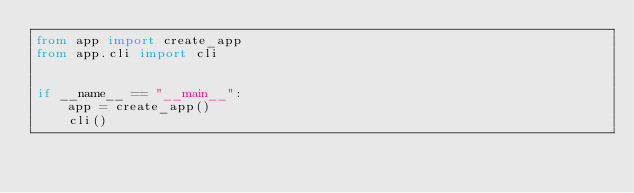<code> <loc_0><loc_0><loc_500><loc_500><_Python_>from app import create_app
from app.cli import cli


if __name__ == "__main__":
    app = create_app()
    cli()
</code> 